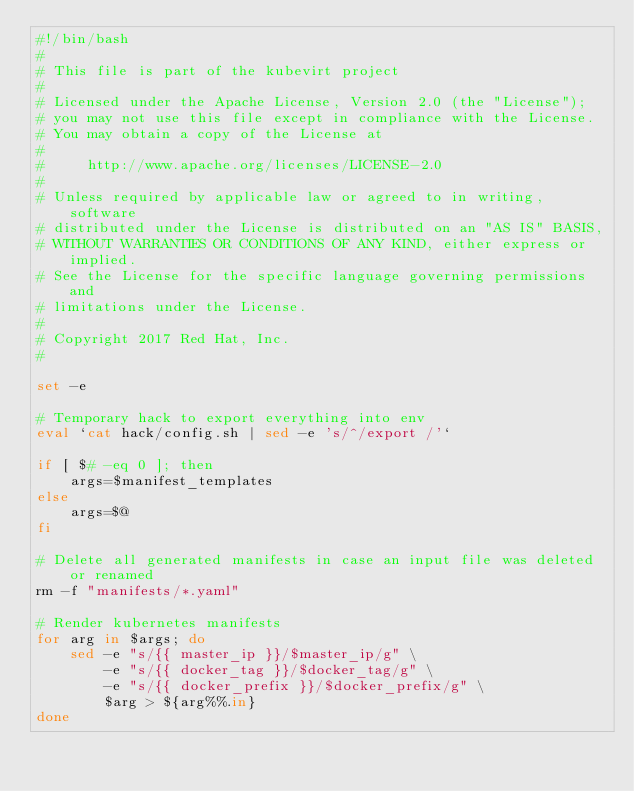<code> <loc_0><loc_0><loc_500><loc_500><_Bash_>#!/bin/bash
#
# This file is part of the kubevirt project
#
# Licensed under the Apache License, Version 2.0 (the "License");
# you may not use this file except in compliance with the License.
# You may obtain a copy of the License at
#
#     http://www.apache.org/licenses/LICENSE-2.0
#
# Unless required by applicable law or agreed to in writing, software
# distributed under the License is distributed on an "AS IS" BASIS,
# WITHOUT WARRANTIES OR CONDITIONS OF ANY KIND, either express or implied.
# See the License for the specific language governing permissions and
# limitations under the License.
#
# Copyright 2017 Red Hat, Inc.
#

set -e

# Temporary hack to export everything into env
eval `cat hack/config.sh | sed -e 's/^/export /'`

if [ $# -eq 0 ]; then
    args=$manifest_templates
else
    args=$@
fi

# Delete all generated manifests in case an input file was deleted or renamed
rm -f "manifests/*.yaml"

# Render kubernetes manifests
for arg in $args; do
    sed -e "s/{{ master_ip }}/$master_ip/g" \
        -e "s/{{ docker_tag }}/$docker_tag/g" \
        -e "s/{{ docker_prefix }}/$docker_prefix/g" \
        $arg > ${arg%%.in}
done
</code> 